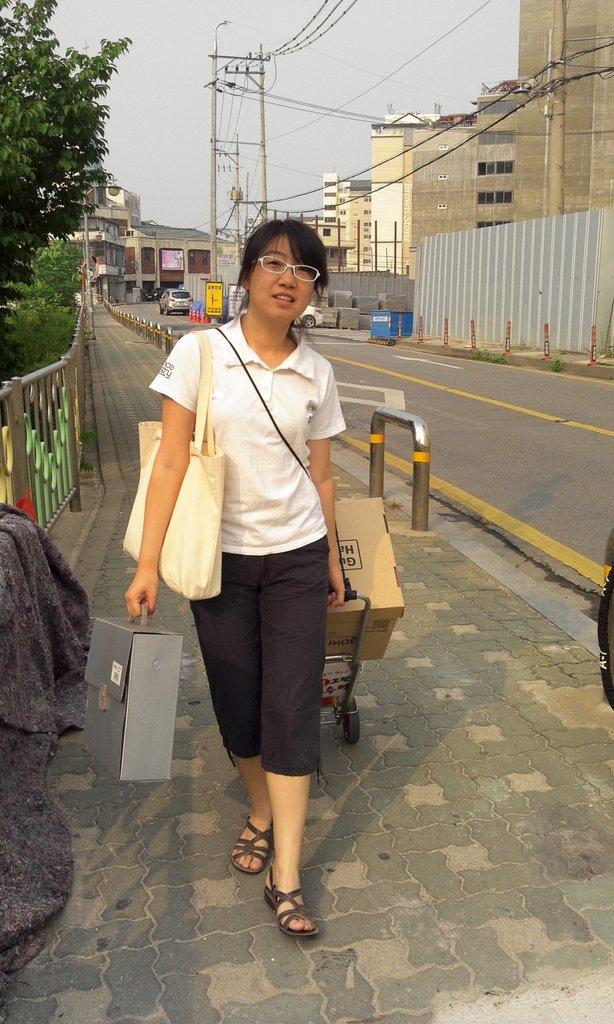How would you summarize this image in a sentence or two? In this image we can see a woman wearing a bag standing on the pathway holding a suitcase and a trolley containing a cardboard box. We can also see a cloth on a fence, a group of plants, some divider poles, some vehicles on the road, some buildings with windows, a street pole, an utility pole with wires, a wall and the sky which looks cloudy. 